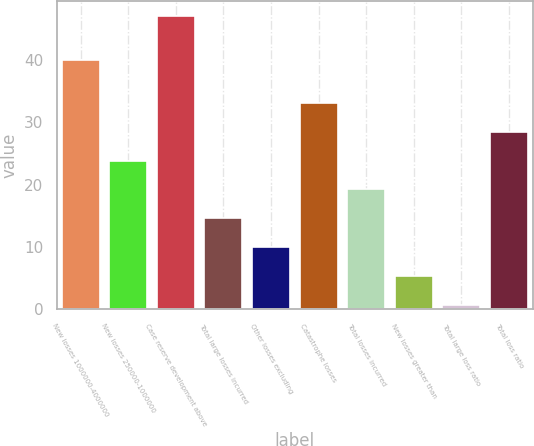Convert chart. <chart><loc_0><loc_0><loc_500><loc_500><bar_chart><fcel>New losses 1000000-4000000<fcel>New losses 250000-1000000<fcel>Case reserve development above<fcel>Total large losses incurred<fcel>Other losses excluding<fcel>Catastrophe losses<fcel>Total losses incurred<fcel>New losses greater than<fcel>Total large loss ratio<fcel>Total loss ratio<nl><fcel>40<fcel>23.85<fcel>47<fcel>14.59<fcel>9.96<fcel>33.11<fcel>19.22<fcel>5.33<fcel>0.7<fcel>28.48<nl></chart> 